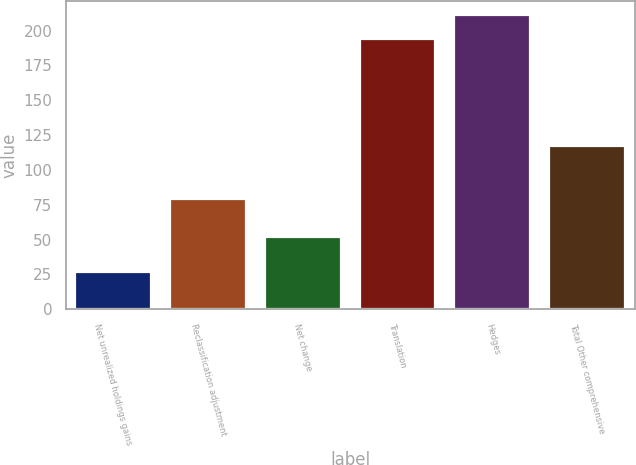Convert chart. <chart><loc_0><loc_0><loc_500><loc_500><bar_chart><fcel>Net unrealized holdings gains<fcel>Reclassification adjustment<fcel>Net change<fcel>Translation<fcel>Hedges<fcel>Total Other comprehensive<nl><fcel>27<fcel>79<fcel>52<fcel>194<fcel>210.9<fcel>117<nl></chart> 